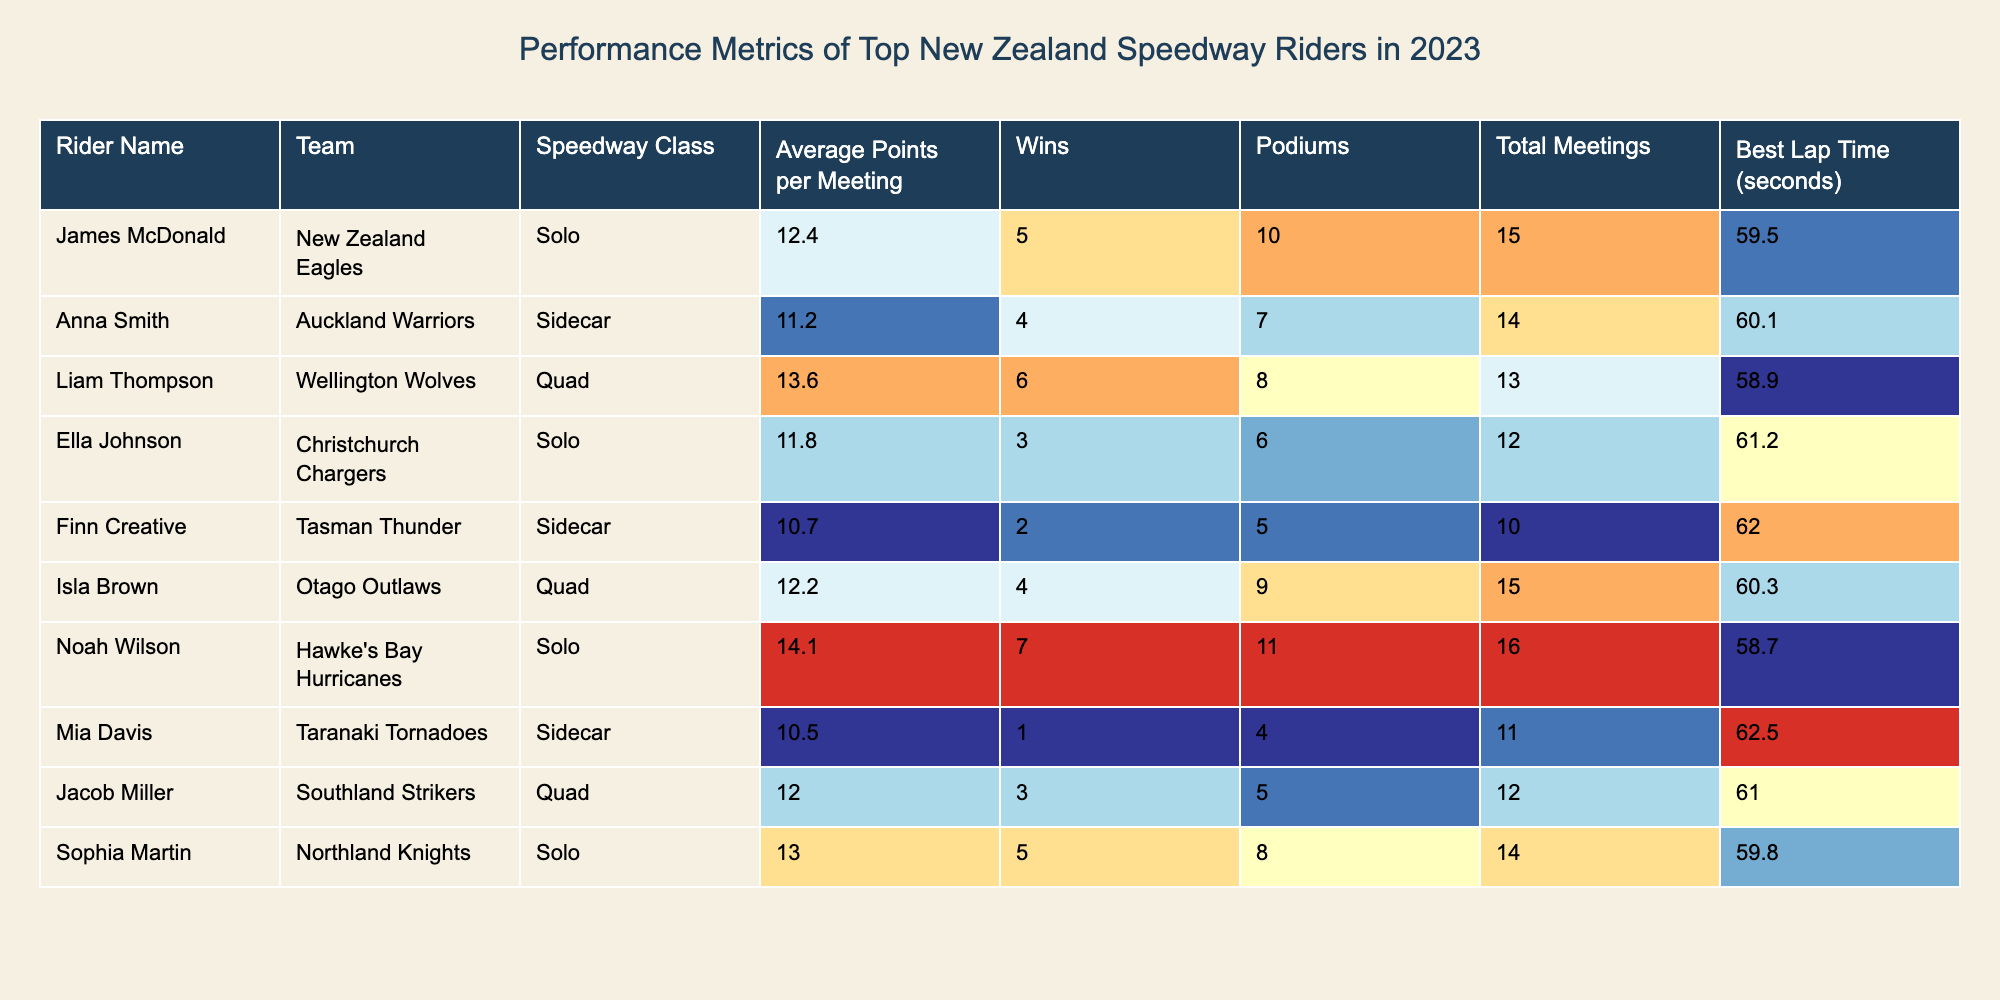What is the highest average points per meeting among the riders? The highest value in the "Average Points per Meeting" column is 14.1, which belongs to Noah Wilson.
Answer: 14.1 Which rider has the best lap time in 2023? Comparing the "Best Lap Time" values, the lowest time is 58.7 seconds, which is recorded by Noah Wilson.
Answer: Noah Wilson How many total meetings did Liam Thompson participate in? The value in the "Total Meetings" column for Liam Thompson is 13.
Answer: 13 What is the difference in average points per meeting between Jacob Miller and Anna Smith? Jacob Miller has 12.0 points per meeting, while Anna Smith has 11.2; thus, the difference is 12.0 - 11.2 = 0.8.
Answer: 0.8 Did Ella Johnson win more podiums than Finn Creative? Ella Johnson has 6 podiums, whereas Finn Creative has 5; therefore, Ella Johnson has indeed won more podiums.
Answer: Yes Who participated in the most total meetings and how many meetings did they have? Reviewing the "Total Meetings" column, Noah Wilson participated in 16 meetings, the highest among all riders.
Answer: 16 Calculate the average number of wins among the top riders listed. The total number of wins is 5 + 4 + 6 + 3 + 2 + 4 + 7 + 1 + 3 + 5 = 40, and there are 10 riders, so the average is 40/10 = 4.
Answer: 4 Which speedway class has the rider with the fastest lap time? Noah Wilson, who competes in the Solo class, has the fastest lap time of 58.7 seconds, indicating that the Solo class has the fastest rider.
Answer: Solo Who has the most wins and what is their associated team? The rider with the most wins is Noah Wilson with 7 wins, and he is part of the Hawke's Bay Hurricanes team.
Answer: Noah Wilson, Hawke's Bay Hurricanes Are there any riders in the Quad class who earned an average of over 12 points per meeting? Isla Brown has an average of 12.2 points per meeting in the Quad class, indicating that there is at least one rider who meets this criterion.
Answer: Yes 